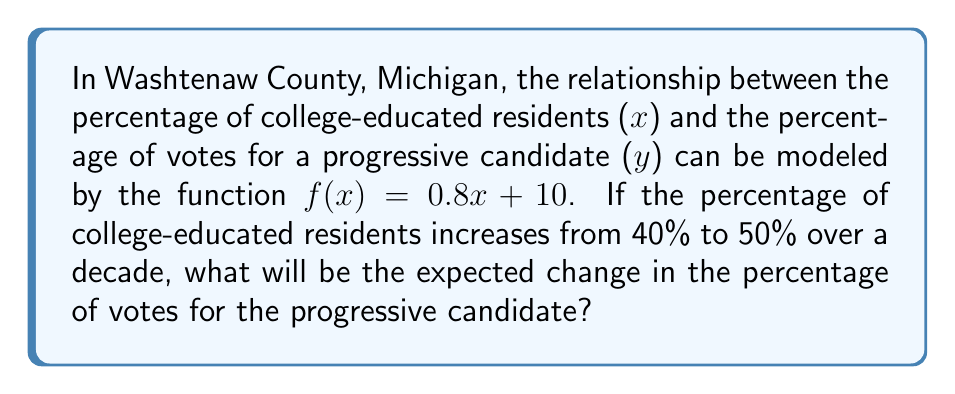Can you answer this question? Let's approach this step-by-step:

1) We are given the function $f(x) = 0.8x + 10$, where:
   - x is the percentage of college-educated residents
   - f(x) is the percentage of votes for the progressive candidate

2) We need to find the difference between f(50) and f(40):

3) First, let's calculate f(40):
   $f(40) = 0.8(40) + 10 = 32 + 10 = 42$

4) Now, let's calculate f(50):
   $f(50) = 0.8(50) + 10 = 40 + 10 = 50$

5) The change in the percentage of votes is the difference between these two values:
   $50 - 42 = 8$

Therefore, the expected change in the percentage of votes for the progressive candidate is an increase of 8 percentage points.
Answer: 8 percentage points 